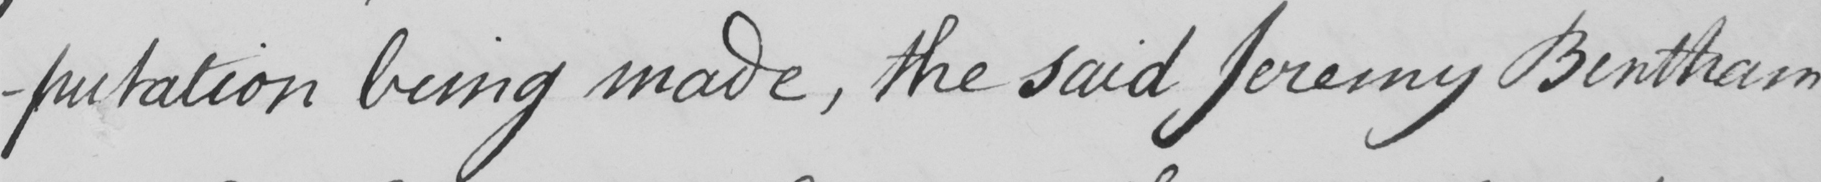Can you read and transcribe this handwriting? -putation being made , the said Jeremy Bentham 